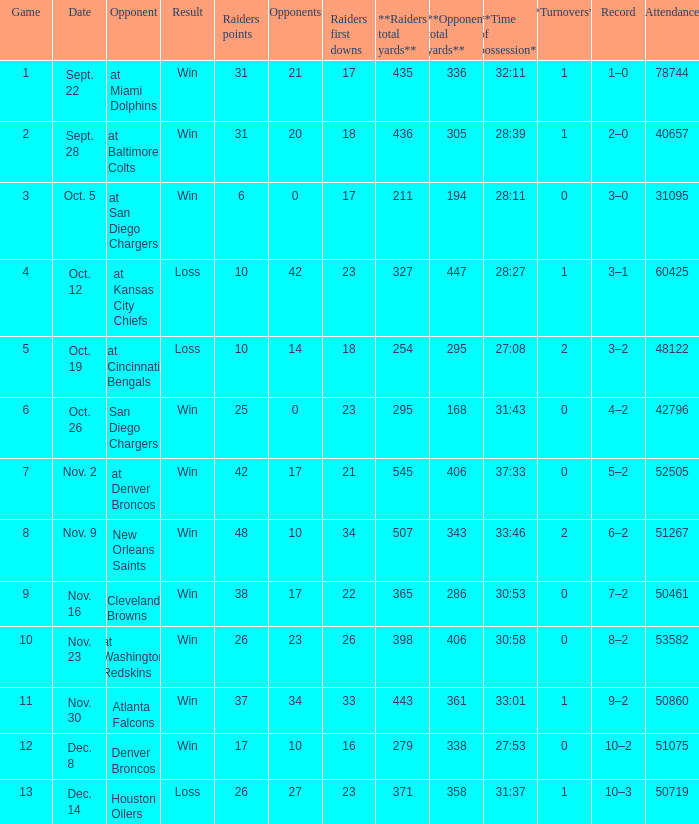What's the record in the game played against 42? 3–1. 